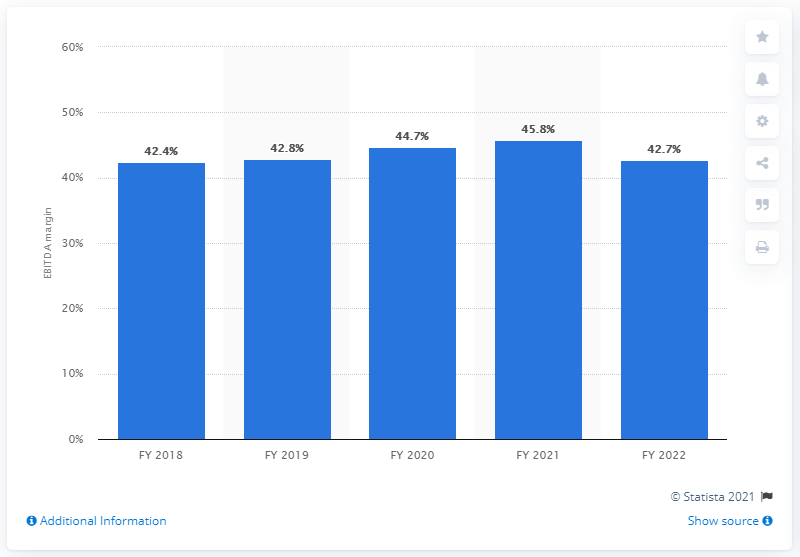Give some essential details in this illustration. At the end of fiscal year 2019, the EBITDA margin of Reliance Jio was 42.7%. 